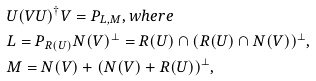<formula> <loc_0><loc_0><loc_500><loc_500>& U ( V U ) ^ { \dag } V = P _ { L , M } , w h e r e \\ & L = P _ { R ( U ) } N ( V ) ^ { \bot } = R ( U ) \cap ( R ( U ) \cap N ( V ) ) ^ { \bot } , \\ & M = N ( V ) + ( N ( V ) + R ( U ) ) ^ { \bot } ,</formula> 